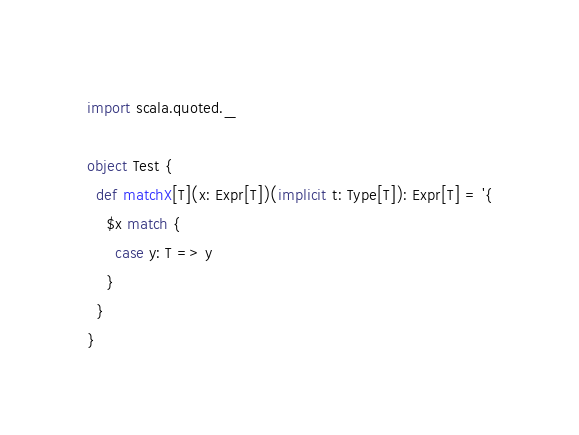<code> <loc_0><loc_0><loc_500><loc_500><_Scala_>
import scala.quoted._

object Test {
  def matchX[T](x: Expr[T])(implicit t: Type[T]): Expr[T] = '{
    $x match {
      case y: T => y
    }
  }
}
</code> 